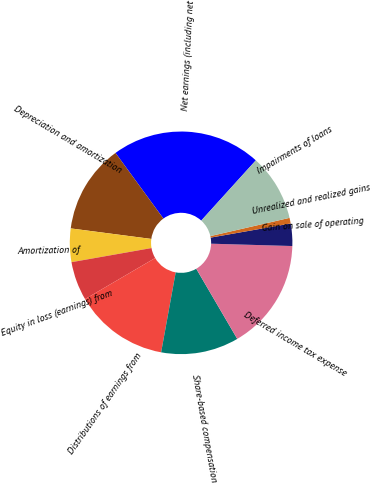Convert chart to OTSL. <chart><loc_0><loc_0><loc_500><loc_500><pie_chart><fcel>Net earnings (including net<fcel>Depreciation and amortization<fcel>Amortization of<fcel>Equity in loss (earnings) from<fcel>Distributions of earnings from<fcel>Share-based compensation<fcel>Deferred income tax expense<fcel>Gain on sale of operating<fcel>Unrealized and realized gains<fcel>Impairments of loans<nl><fcel>21.75%<fcel>12.9%<fcel>4.85%<fcel>5.65%<fcel>13.7%<fcel>11.29%<fcel>16.12%<fcel>3.24%<fcel>0.82%<fcel>9.68%<nl></chart> 